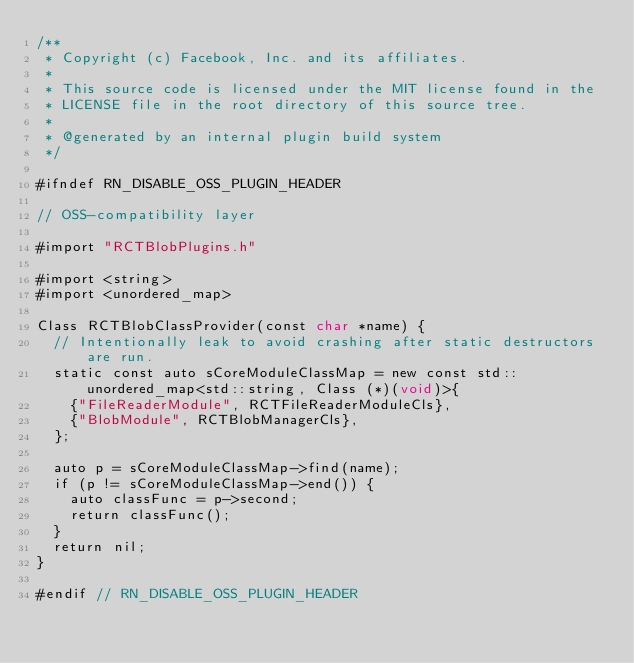<code> <loc_0><loc_0><loc_500><loc_500><_ObjectiveC_>/**
 * Copyright (c) Facebook, Inc. and its affiliates.
 *
 * This source code is licensed under the MIT license found in the
 * LICENSE file in the root directory of this source tree.
 *
 * @generated by an internal plugin build system
 */

#ifndef RN_DISABLE_OSS_PLUGIN_HEADER

// OSS-compatibility layer

#import "RCTBlobPlugins.h"

#import <string>
#import <unordered_map>

Class RCTBlobClassProvider(const char *name) {
  // Intentionally leak to avoid crashing after static destructors are run.
  static const auto sCoreModuleClassMap = new const std::unordered_map<std::string, Class (*)(void)>{
    {"FileReaderModule", RCTFileReaderModuleCls},
    {"BlobModule", RCTBlobManagerCls},
  };

  auto p = sCoreModuleClassMap->find(name);
  if (p != sCoreModuleClassMap->end()) {
    auto classFunc = p->second;
    return classFunc();
  }
  return nil;
}

#endif // RN_DISABLE_OSS_PLUGIN_HEADER
</code> 